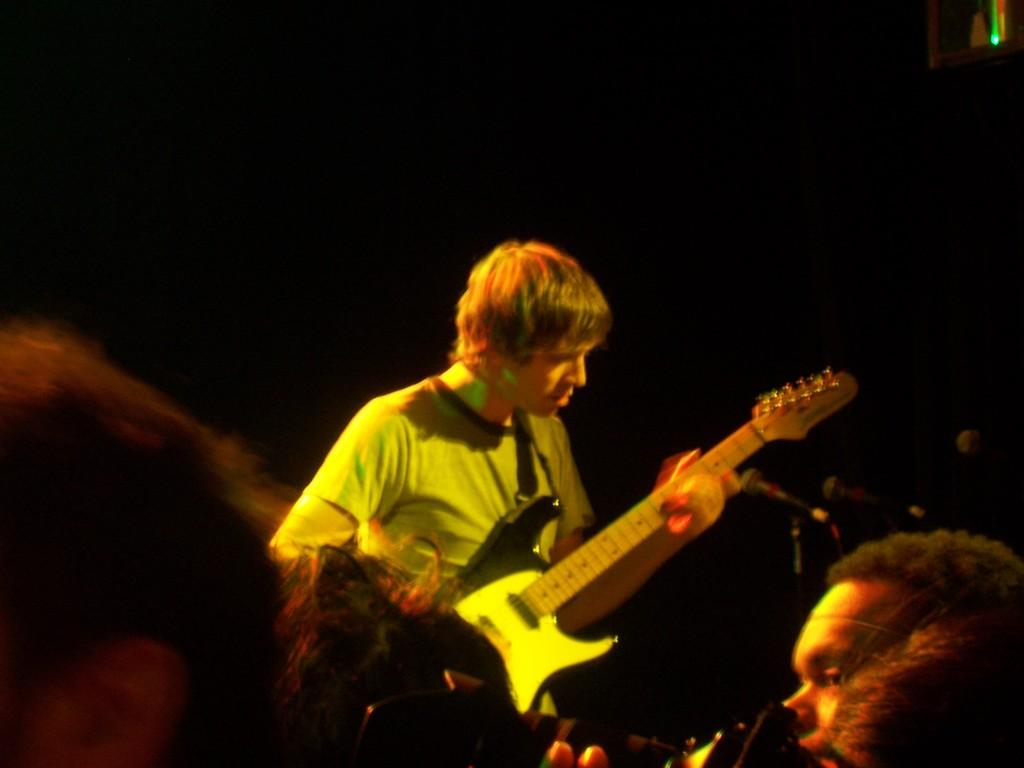What is the person in the image holding? The person is holding a guitar in the image. Can you describe the people in the image besides the person holding the guitar? There are the heads of a few people visible in the image. What other objects can be seen in the image? There are other objects in the image, but their specific details are not mentioned in the provided facts. How would you describe the background of the image? The background of the image has a dark view. What position does the lead guitarist play in the image? There is no mention of a lead guitarist or any specific position in the image. 